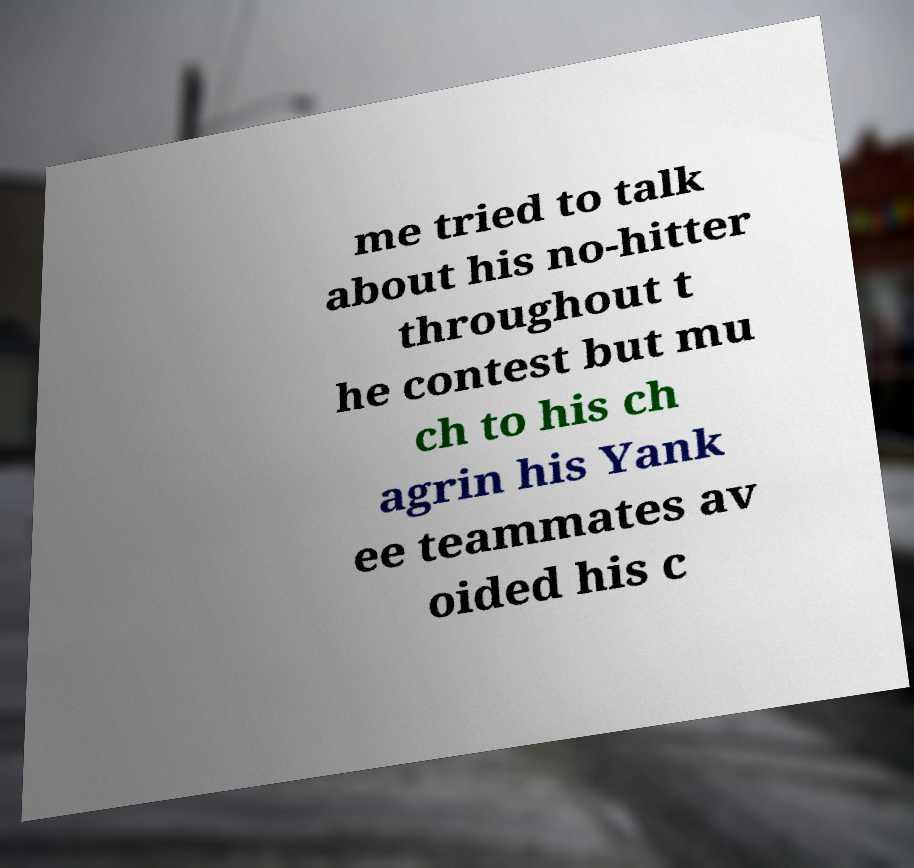Please identify and transcribe the text found in this image. me tried to talk about his no-hitter throughout t he contest but mu ch to his ch agrin his Yank ee teammates av oided his c 